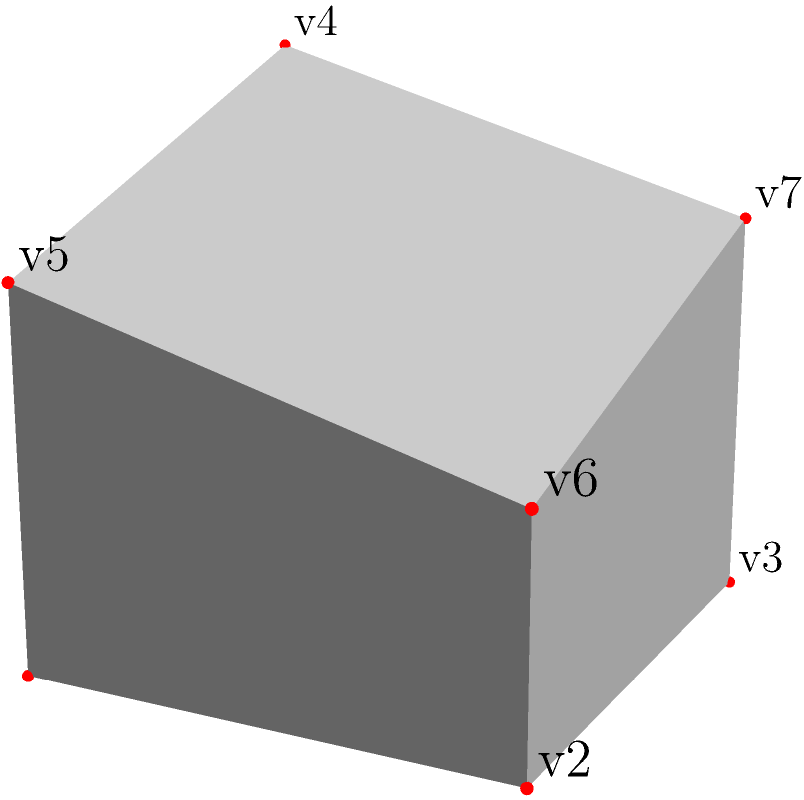The irregular polyhedron shown represents a simplified 3D model of a complex animal call sonogram. The base is a 2x2 square, and the top face is a trapezoid. Given that the heights at the vertices v4, v5, v6, and v7 are 2, 1.5, 1, and 1.5 units respectively, calculate the total surface area of this polyhedron. To find the total surface area, we need to calculate the area of each face and sum them up:

1. Base (bottom face):
   Area = $2 \times 2 = 4$ square units

2. Top face (trapezoid):
   Area = $\frac{1}{2}(2 + 2) \times 2 = 4$ square units

3. Front face (trapezoid):
   Height = $2$, Width = $2$, Slant height = $\sqrt{2^2 + 0.5^2} = \sqrt{4.25} \approx 2.06$
   Area = $\frac{1}{2}(2 + 2) \times 2.06 \approx 4.12$ square units

4. Back face (trapezoid):
   Height = $1.5$, Width = $2$, Slant height = $\sqrt{2^2 + 0.5^2} = \sqrt{4.25} \approx 2.06$
   Area = $\frac{1}{2}(2 + 2) \times 2.06 \approx 4.12$ square units

5. Left face (trapezoid):
   Base = $2$, Top = $1.5$, Height = $2$
   Area = $\frac{1}{2}(2 + 1.5) \times 2 = 3.5$ square units

6. Right face (trapezoid):
   Base = $2$, Top = $1$, Height = $2$
   Area = $\frac{1}{2}(2 + 1) \times 2 = 3$ square units

Total surface area = Sum of all face areas
$$ 4 + 4 + 4.12 + 4.12 + 3.5 + 3 = 22.74 $$

Therefore, the total surface area is approximately 22.74 square units.
Answer: 22.74 square units 